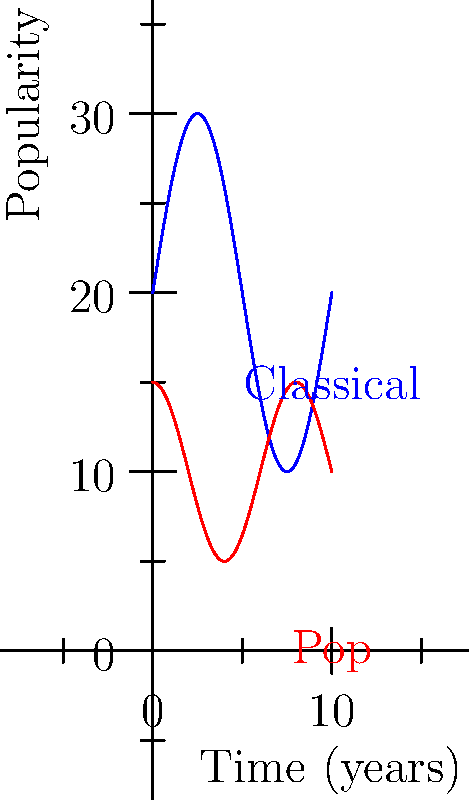The graph shows the popularity of Classical and Pop music genres over a 10-year period. The blue curve represents Classical music, given by the function $f(x) = 20 + 10\sin(\frac{\pi x}{5})$, and the red curve represents Pop music, given by $g(x) = 10 + 5\cos(\frac{\pi x}{4})$, where $x$ is time in years and $y$ is popularity on a scale of 0-100. Calculate the difference between the total popularity of Classical music and Pop music over the 10-year period by finding the difference in the areas under their respective curves. To solve this problem, we need to calculate the definite integrals of both functions over the interval [0, 10] and then find their difference.

1. For Classical music:
   $$\int_0^{10} f(x) dx = \int_0^{10} (20 + 10\sin(\frac{\pi x}{5})) dx$$
   $$= [20x - \frac{50}{\pi}\cos(\frac{\pi x}{5})]_0^{10}$$
   $$= (200 - \frac{50}{\pi}\cos(2\pi)) - (0 - \frac{50}{\pi})$$
   $$= 200 - \frac{50}{\pi} + \frac{50}{\pi} = 200$$

2. For Pop music:
   $$\int_0^{10} g(x) dx = \int_0^{10} (10 + 5\cos(\frac{\pi x}{4})) dx$$
   $$= [10x + \frac{20}{\pi}\sin(\frac{\pi x}{4})]_0^{10}$$
   $$= (100 + \frac{20}{\pi}\sin(\frac{5\pi}{2})) - (0 + 0)$$
   $$= 100$$

3. The difference in total popularity:
   Classical - Pop = 200 - 100 = 100
Answer: 100 popularity-years 